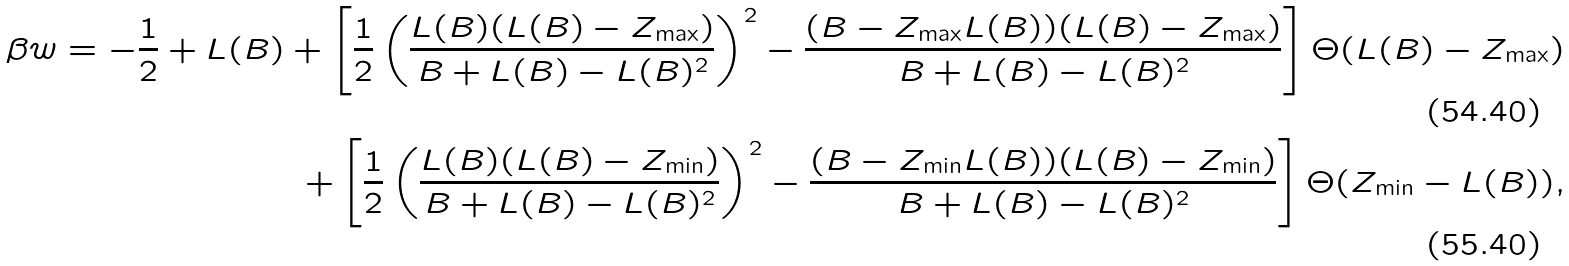Convert formula to latex. <formula><loc_0><loc_0><loc_500><loc_500>\beta w = - \frac { 1 } { 2 } + L ( B ) + \left [ \frac { 1 } { 2 } \left ( \frac { L ( B ) ( L ( B ) - Z _ { \max } ) } { B + L ( B ) - L ( B ) ^ { 2 } } \right ) ^ { 2 } - \frac { ( B - Z _ { \max } L ( B ) ) ( L ( B ) - Z _ { \max } ) } { B + L ( B ) - L ( B ) ^ { 2 } } \right ] \Theta ( L ( B ) - Z _ { \max } ) \\ + \left [ \frac { 1 } { 2 } \left ( \frac { L ( B ) ( L ( B ) - Z _ { \min } ) } { B + L ( B ) - L ( B ) ^ { 2 } } \right ) ^ { 2 } - \frac { ( B - Z _ { \min } L ( B ) ) ( L ( B ) - Z _ { \min } ) } { B + L ( B ) - L ( B ) ^ { 2 } } \right ] \Theta ( Z _ { \min } - L ( B ) ) ,</formula> 